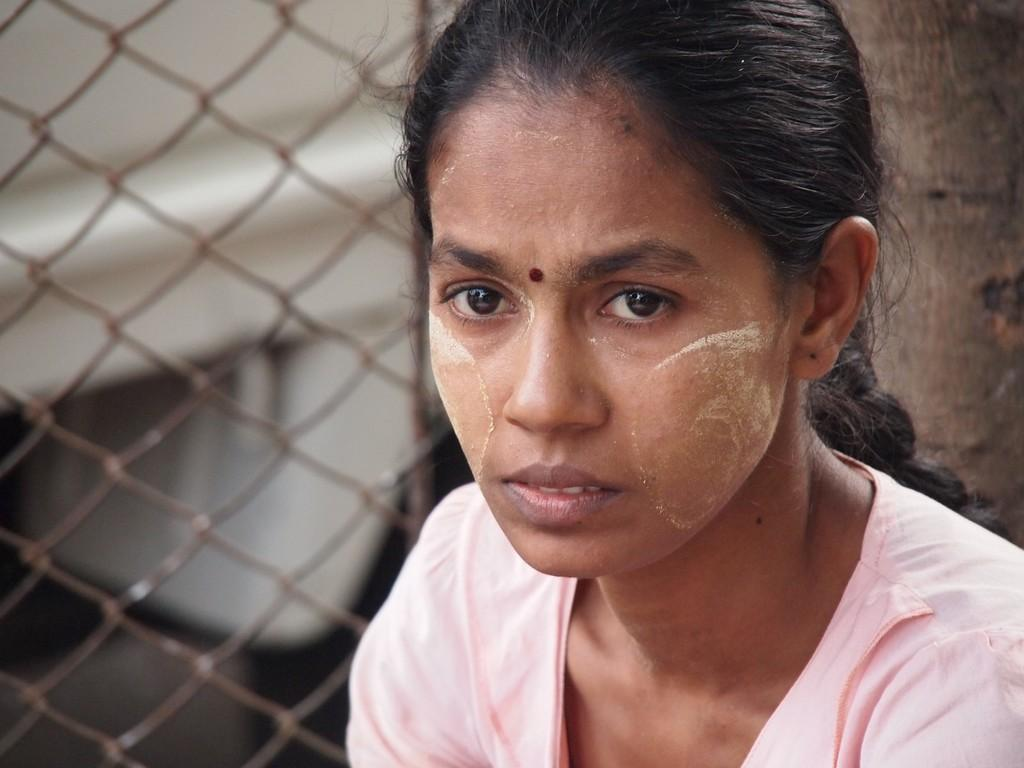Who is present in the image? There is a woman in the image. What can be seen in the background or surrounding the woman? There is fencing in the image. What type of honey is being collected by the woman in the image? There is no honey or honey collection activity present in the image. 